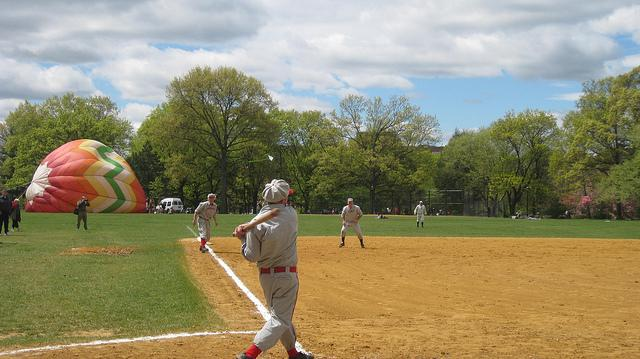What type of transport is visible here?

Choices:
A) car
B) plane
C) hotair balloon
D) bike hotair balloon 